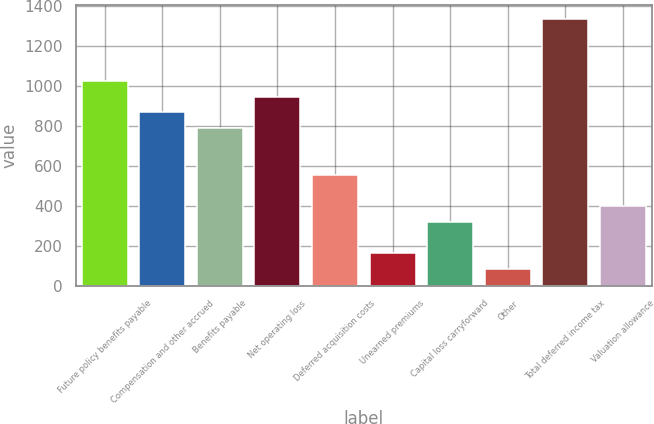Convert chart to OTSL. <chart><loc_0><loc_0><loc_500><loc_500><bar_chart><fcel>Future policy benefits payable<fcel>Compensation and other accrued<fcel>Benefits payable<fcel>Net operating loss<fcel>Deferred acquisition costs<fcel>Unearned premiums<fcel>Capital loss carryforward<fcel>Other<fcel>Total deferred income tax<fcel>Valuation allowance<nl><fcel>1024.42<fcel>867.5<fcel>789.04<fcel>945.96<fcel>553.66<fcel>161.36<fcel>318.28<fcel>82.9<fcel>1338.26<fcel>396.74<nl></chart> 